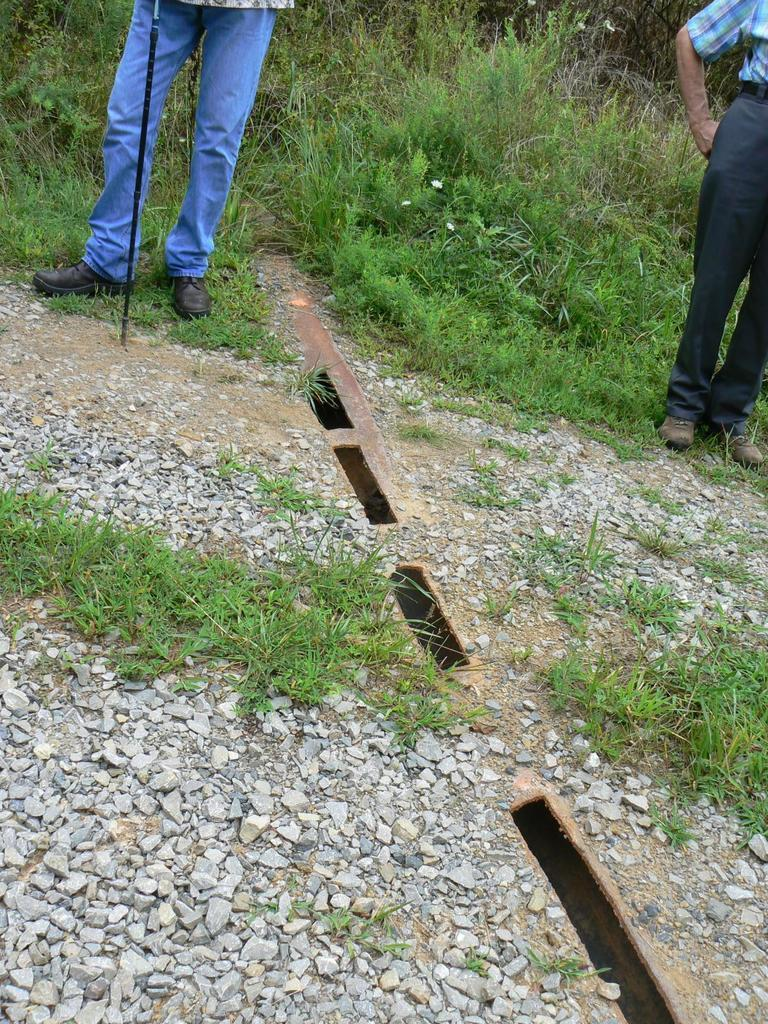How many people are in the image? There are two people standing in the image. What is the surface they are standing on? The people are standing on the ground. What type of natural elements can be seen in the image? Stones and grass are visible in the image. What object can be seen in the image that might be used for support or as a tool? There is a stick in the image. What can be seen in the background of the image? There are plants in the background of the image. What type of slave is depicted in the image? There is no slave depicted in the image; it features two people standing on the ground. What type of stew is being prepared in the image? There is no stew being prepared in the image; it shows people standing on the ground with stones, grass, and a stick. 